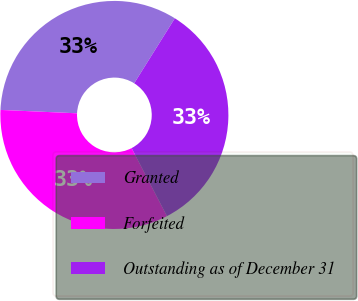Convert chart to OTSL. <chart><loc_0><loc_0><loc_500><loc_500><pie_chart><fcel>Granted<fcel>Forfeited<fcel>Outstanding as of December 31<nl><fcel>33.19%<fcel>33.33%<fcel>33.47%<nl></chart> 